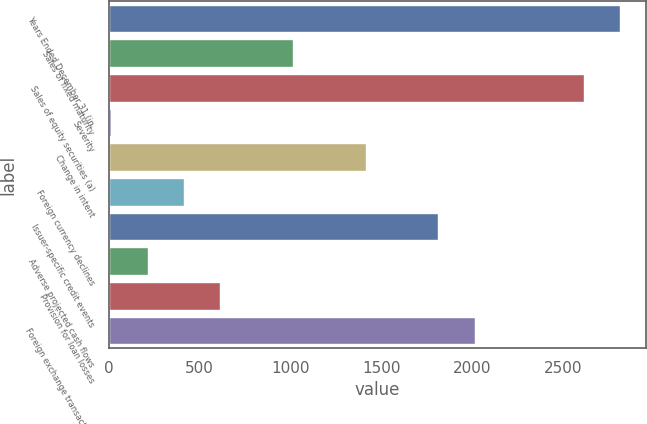<chart> <loc_0><loc_0><loc_500><loc_500><bar_chart><fcel>Years Ended December 31 (in<fcel>Sales of fixed maturity<fcel>Sales of equity securities (a)<fcel>Severity<fcel>Change in intent<fcel>Foreign currency declines<fcel>Issuer-specific credit events<fcel>Adverse projected cash flows<fcel>Provision for loan losses<fcel>Foreign exchange transactions<nl><fcel>2815.8<fcel>1014<fcel>2615.6<fcel>13<fcel>1414.4<fcel>413.4<fcel>1814.8<fcel>213.2<fcel>613.6<fcel>2015<nl></chart> 